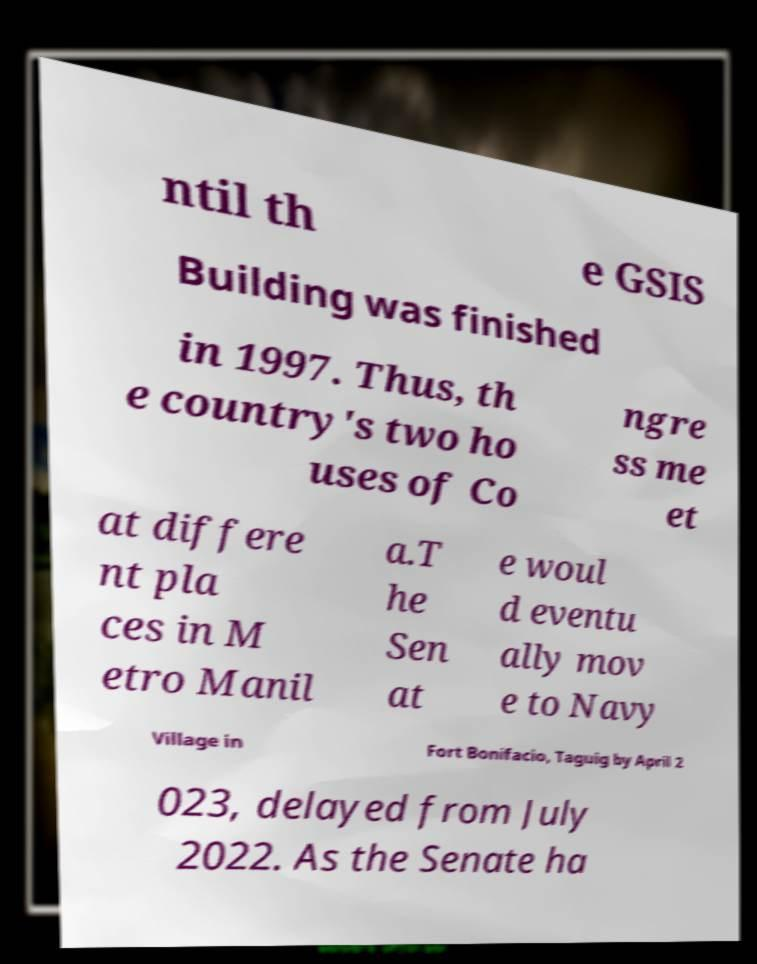Can you read and provide the text displayed in the image?This photo seems to have some interesting text. Can you extract and type it out for me? ntil th e GSIS Building was finished in 1997. Thus, th e country's two ho uses of Co ngre ss me et at differe nt pla ces in M etro Manil a.T he Sen at e woul d eventu ally mov e to Navy Village in Fort Bonifacio, Taguig by April 2 023, delayed from July 2022. As the Senate ha 